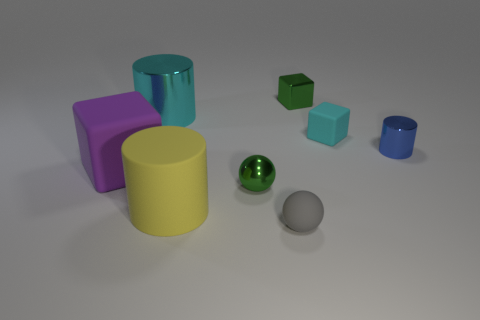Subtract all tiny blue metal cylinders. How many cylinders are left? 2 Add 2 small rubber spheres. How many objects exist? 10 Subtract all blue cylinders. How many cylinders are left? 2 Subtract all cylinders. How many objects are left? 5 Add 6 tiny green cubes. How many tiny green cubes exist? 7 Subtract 1 green cubes. How many objects are left? 7 Subtract 1 cubes. How many cubes are left? 2 Subtract all purple cylinders. Subtract all purple balls. How many cylinders are left? 3 Subtract all large purple metallic cylinders. Subtract all green objects. How many objects are left? 6 Add 7 cyan metallic things. How many cyan metallic things are left? 8 